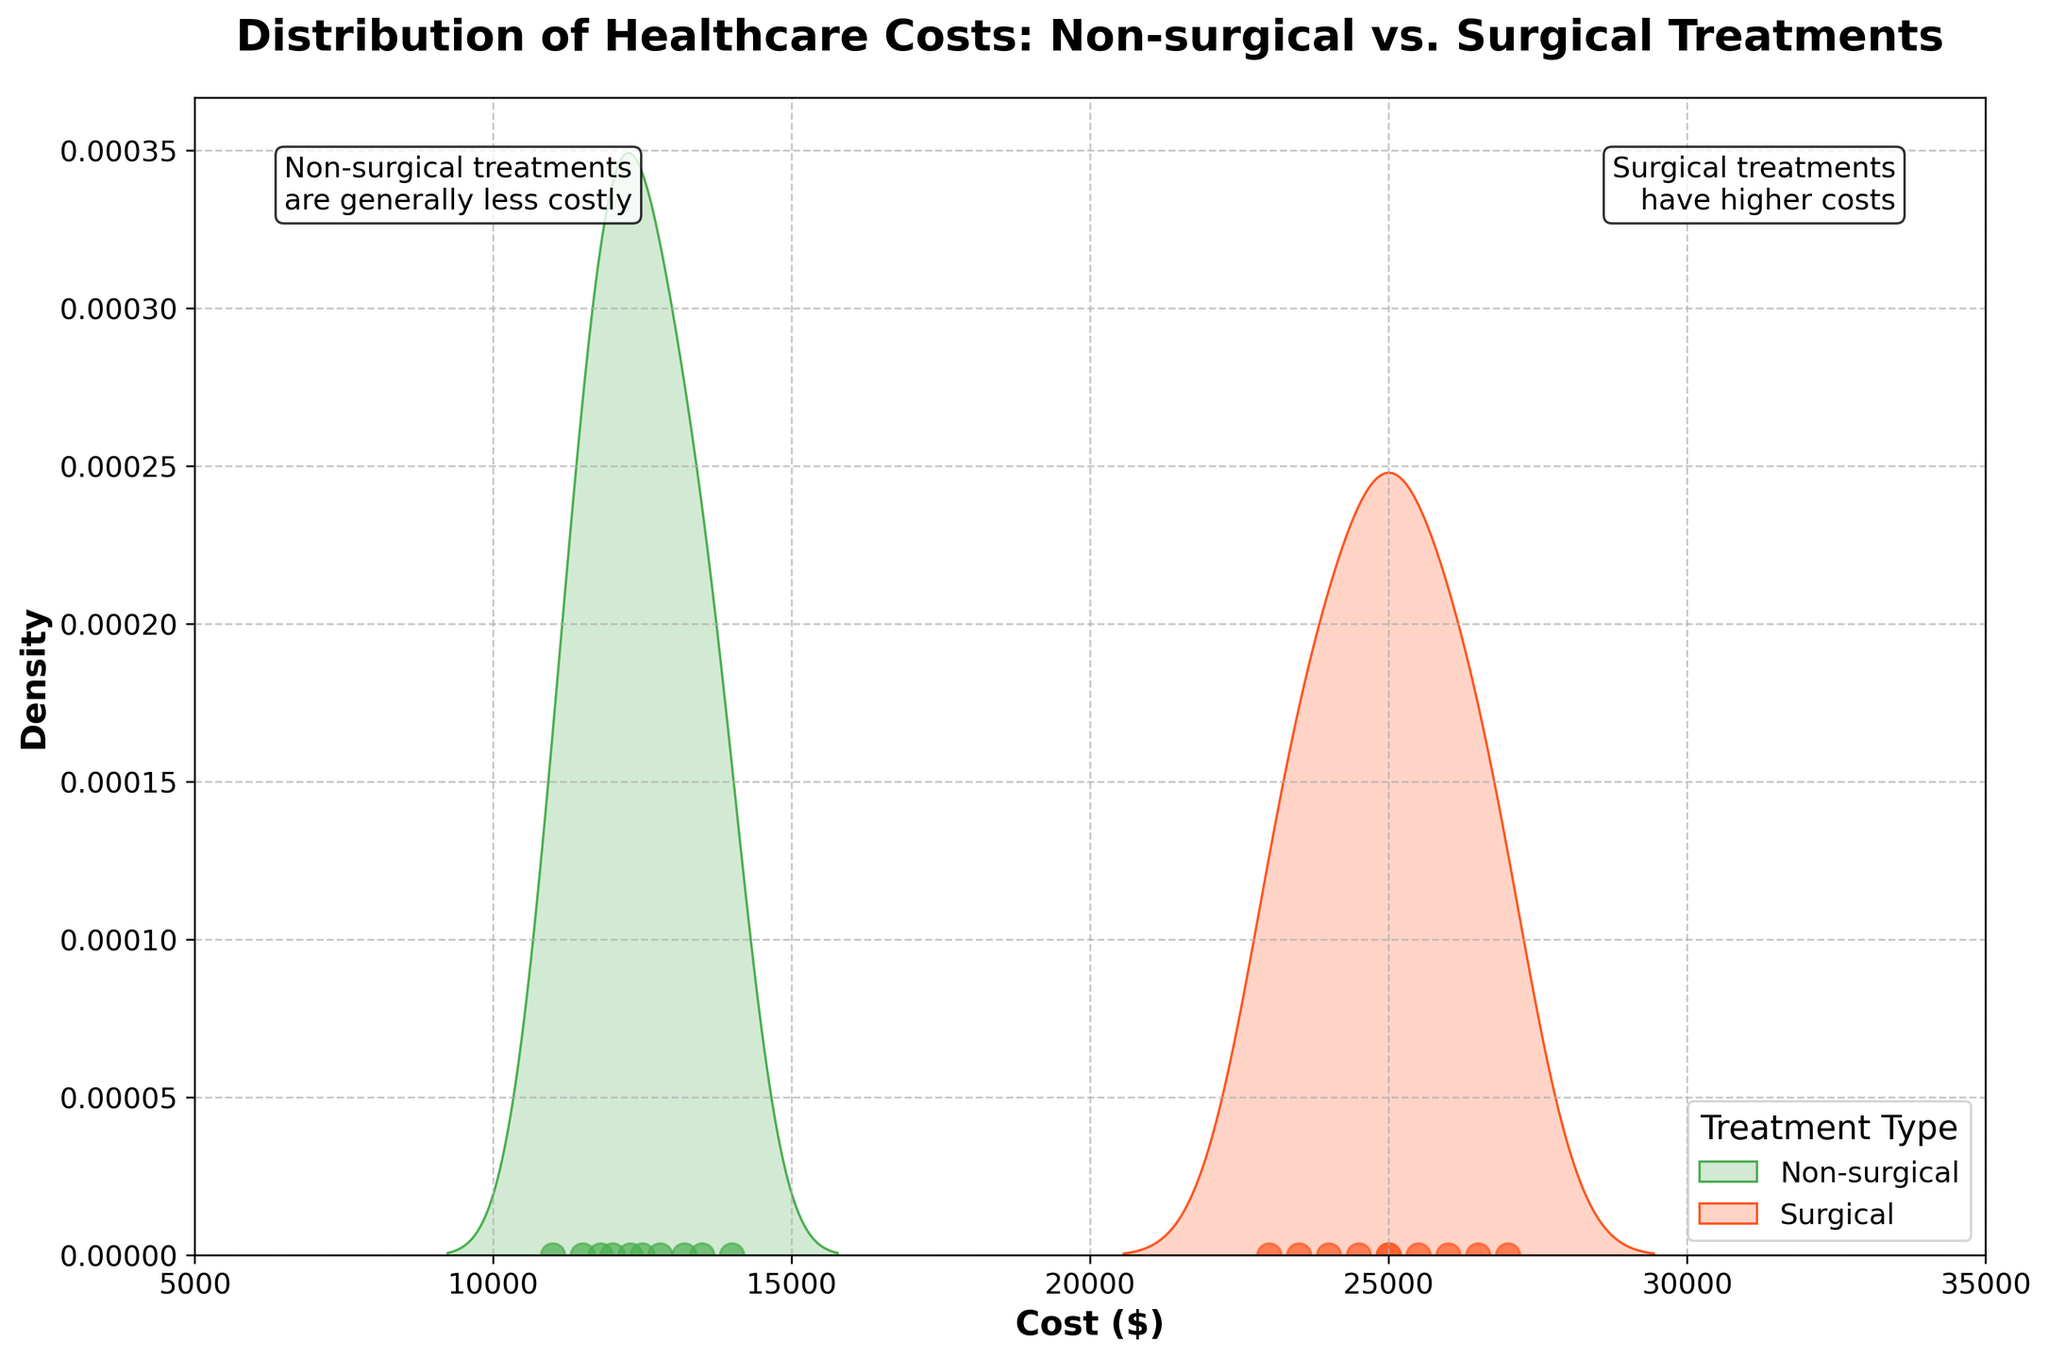what is the title of the figure? The title of the figure is displayed at the top of the plot in bold. You can see it reads "Distribution of Healthcare Costs: Non-surgical vs. Surgical Treatments."
Answer: Distribution of Healthcare Costs: Non-surgical vs. Surgical Treatments what are the two treatment types compared in the figure? By looking at the labels and text annotations, it is clear that the figure compares "Non-surgical" and "Surgical" treatments.
Answer: Non-surgical and Surgical which treatment has higher costs in comparison? The text annotations indicate that "Surgical treatments have higher costs" and "Non-surgical treatments are generally less costly," and this is visually supported by the placement and shape of the distributions.
Answer: Surgical what is the color used to represent non-surgical treatments? The non-surgical treatments are represented by a green shade, as indicated by the green density plot and the green scatter points.
Answer: Green what is the range of costs for non-surgical treatments? By observing the spread of the green density plot and the scatter points, the range of costs for non-surgical treatments is approximately between $11,000 and $14,000.
Answer: $11,000 to $14,000 what is the median cost of surgical treatments? Observing the peak and central tendency of the orange density plot, the major cluster of surgical costs is centered around some typical values. Given that 10 data points are present for each group and their values are between $23,000 and $27,000, the median value is around the 5th or 6th data point's central value near $25,000.
Answer: Around $25,000 are there more non-surgical or surgical treatment data points? Both treatments have exactly 10 data points each, as evidenced by the scatter points along the zero-density line for both green (non-surgical) and orange (surgical) treatments.
Answer: Equal number of data points how are scatter points in the figure used to show the data? Scatter points are plotted along the zero-density line for both non-surgical (green) and surgical (orange) treatments to show the individual cost data points clearly without overlapping the density plots.
Answer: To show individual cost data points which treatment type has a wider spread in costs? The surgical treatment (orange) has a wider spread in its distribution, ranging from $23,000 to $27,000, compared to the more tightly clustered non-surgical costs.
Answer: Surgical 